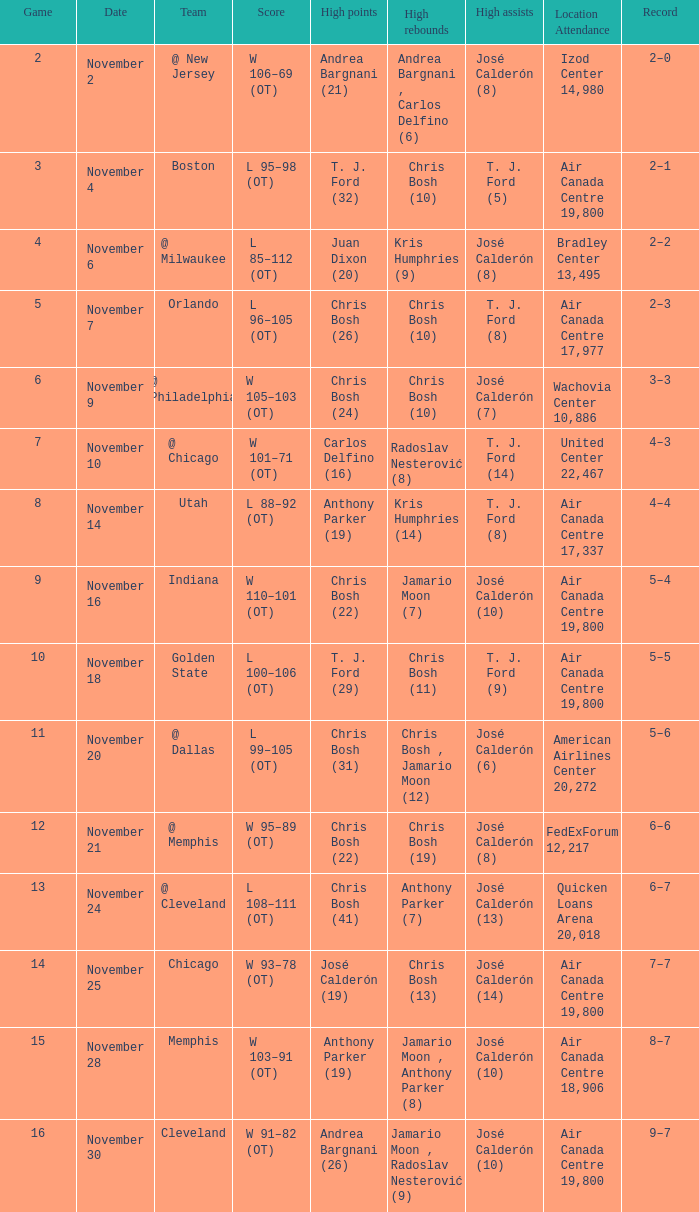Who had the high rebounds when the game number was 6? Chris Bosh (10). 